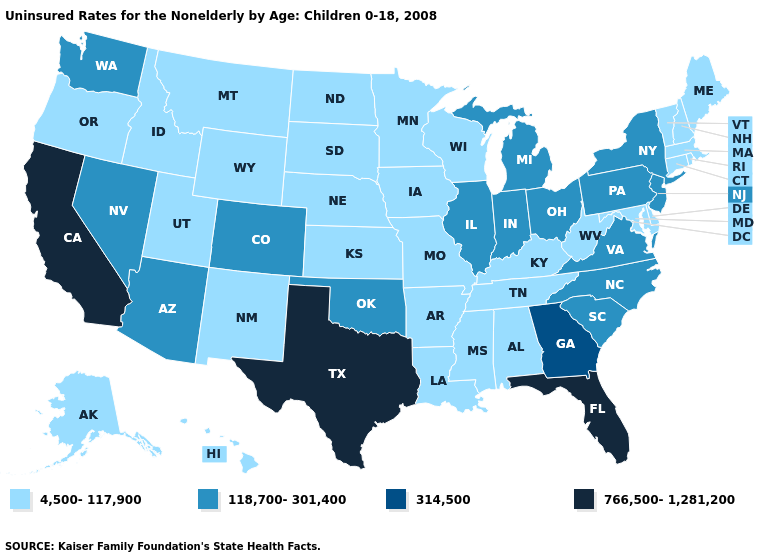Name the states that have a value in the range 118,700-301,400?
Keep it brief. Arizona, Colorado, Illinois, Indiana, Michigan, Nevada, New Jersey, New York, North Carolina, Ohio, Oklahoma, Pennsylvania, South Carolina, Virginia, Washington. Among the states that border Montana , which have the highest value?
Be succinct. Idaho, North Dakota, South Dakota, Wyoming. Name the states that have a value in the range 4,500-117,900?
Give a very brief answer. Alabama, Alaska, Arkansas, Connecticut, Delaware, Hawaii, Idaho, Iowa, Kansas, Kentucky, Louisiana, Maine, Maryland, Massachusetts, Minnesota, Mississippi, Missouri, Montana, Nebraska, New Hampshire, New Mexico, North Dakota, Oregon, Rhode Island, South Dakota, Tennessee, Utah, Vermont, West Virginia, Wisconsin, Wyoming. Name the states that have a value in the range 766,500-1,281,200?
Quick response, please. California, Florida, Texas. How many symbols are there in the legend?
Quick response, please. 4. Does California have the highest value in the USA?
Answer briefly. Yes. Which states have the lowest value in the South?
Keep it brief. Alabama, Arkansas, Delaware, Kentucky, Louisiana, Maryland, Mississippi, Tennessee, West Virginia. Among the states that border Wyoming , does Idaho have the highest value?
Answer briefly. No. Name the states that have a value in the range 314,500?
Answer briefly. Georgia. What is the value of New York?
Quick response, please. 118,700-301,400. What is the value of Oregon?
Answer briefly. 4,500-117,900. Among the states that border Delaware , which have the lowest value?
Answer briefly. Maryland. Name the states that have a value in the range 118,700-301,400?
Answer briefly. Arizona, Colorado, Illinois, Indiana, Michigan, Nevada, New Jersey, New York, North Carolina, Ohio, Oklahoma, Pennsylvania, South Carolina, Virginia, Washington. Name the states that have a value in the range 314,500?
Give a very brief answer. Georgia. Does Maine have the lowest value in the USA?
Be succinct. Yes. 